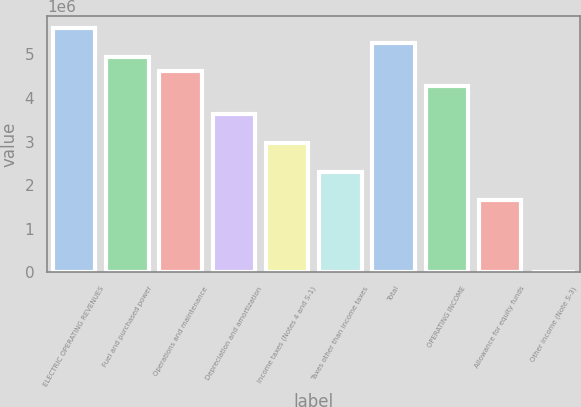Convert chart to OTSL. <chart><loc_0><loc_0><loc_500><loc_500><bar_chart><fcel>ELECTRIC OPERATING REVENUES<fcel>Fuel and purchased power<fcel>Operations and maintenance<fcel>Depreciation and amortization<fcel>Income taxes (Notes 4 and S-1)<fcel>Taxes other than income taxes<fcel>Total<fcel>OPERATING INCOME<fcel>Allowance for equity funds<fcel>Other income (Note S-3)<nl><fcel>5.59692e+06<fcel>4.9388e+06<fcel>4.60974e+06<fcel>3.62255e+06<fcel>2.96443e+06<fcel>2.3063e+06<fcel>5.26786e+06<fcel>4.28068e+06<fcel>1.64818e+06<fcel>2868<nl></chart> 